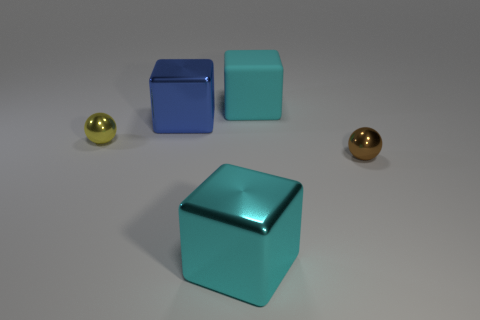Add 3 yellow things. How many objects exist? 8 Subtract all cyan cubes. How many cubes are left? 1 Subtract all blocks. How many objects are left? 2 Subtract all blue cubes. How many cubes are left? 2 Subtract 1 blocks. How many blocks are left? 2 Subtract all gray blocks. How many gray spheres are left? 0 Add 2 yellow things. How many yellow things are left? 3 Add 3 big green metallic cubes. How many big green metallic cubes exist? 3 Subtract 0 brown blocks. How many objects are left? 5 Subtract all green spheres. Subtract all purple cylinders. How many spheres are left? 2 